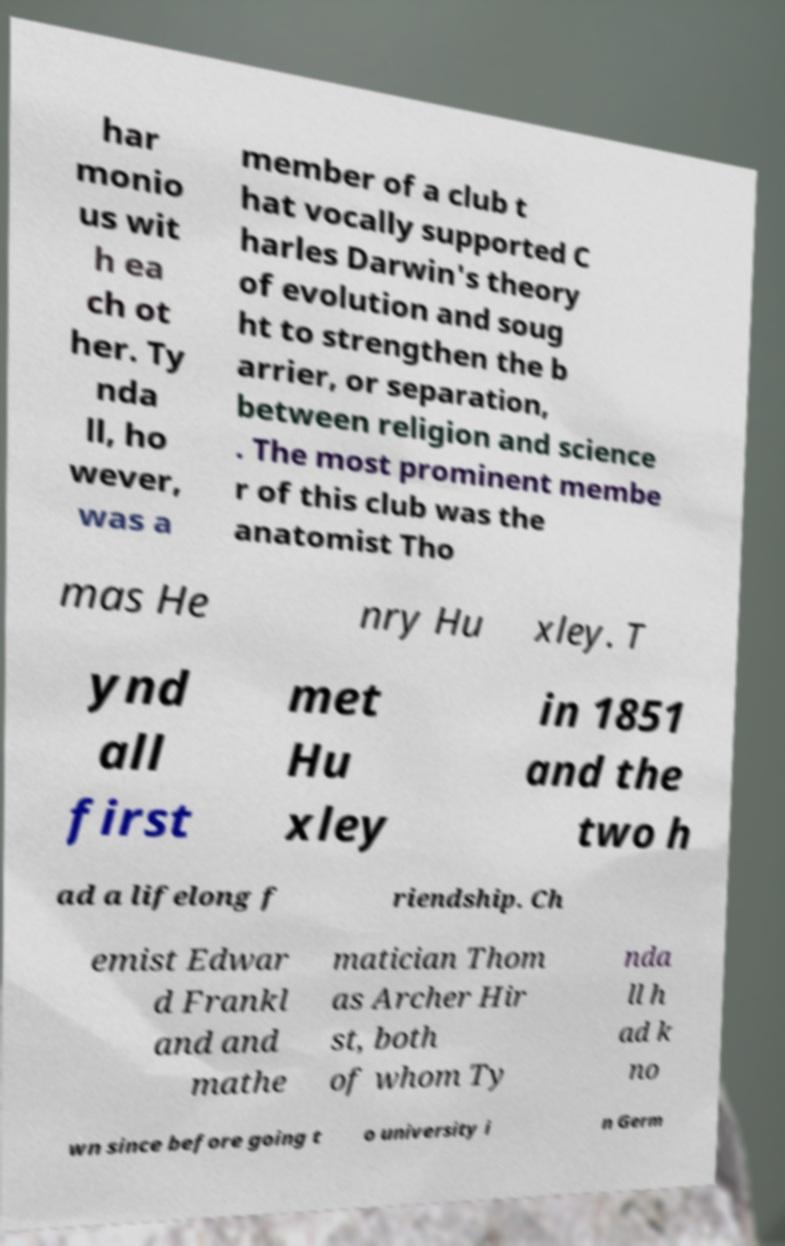Could you assist in decoding the text presented in this image and type it out clearly? har monio us wit h ea ch ot her. Ty nda ll, ho wever, was a member of a club t hat vocally supported C harles Darwin's theory of evolution and soug ht to strengthen the b arrier, or separation, between religion and science . The most prominent membe r of this club was the anatomist Tho mas He nry Hu xley. T ynd all first met Hu xley in 1851 and the two h ad a lifelong f riendship. Ch emist Edwar d Frankl and and mathe matician Thom as Archer Hir st, both of whom Ty nda ll h ad k no wn since before going t o university i n Germ 